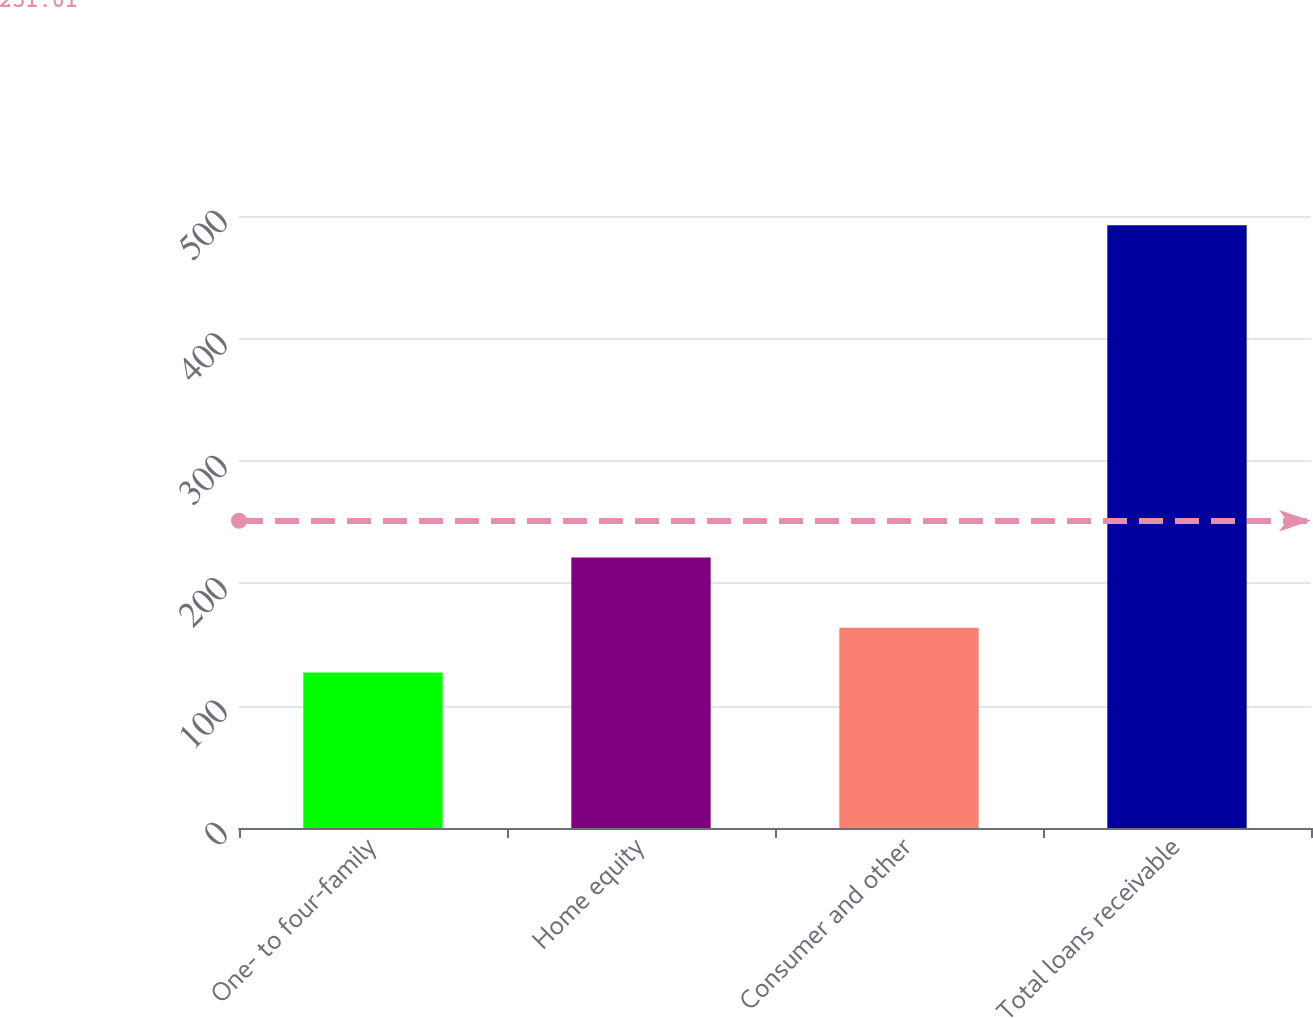Convert chart. <chart><loc_0><loc_0><loc_500><loc_500><bar_chart><fcel>One- to four-family<fcel>Home equity<fcel>Consumer and other<fcel>Total loans receivable<nl><fcel>127.1<fcel>220.9<fcel>163.63<fcel>492.4<nl></chart> 